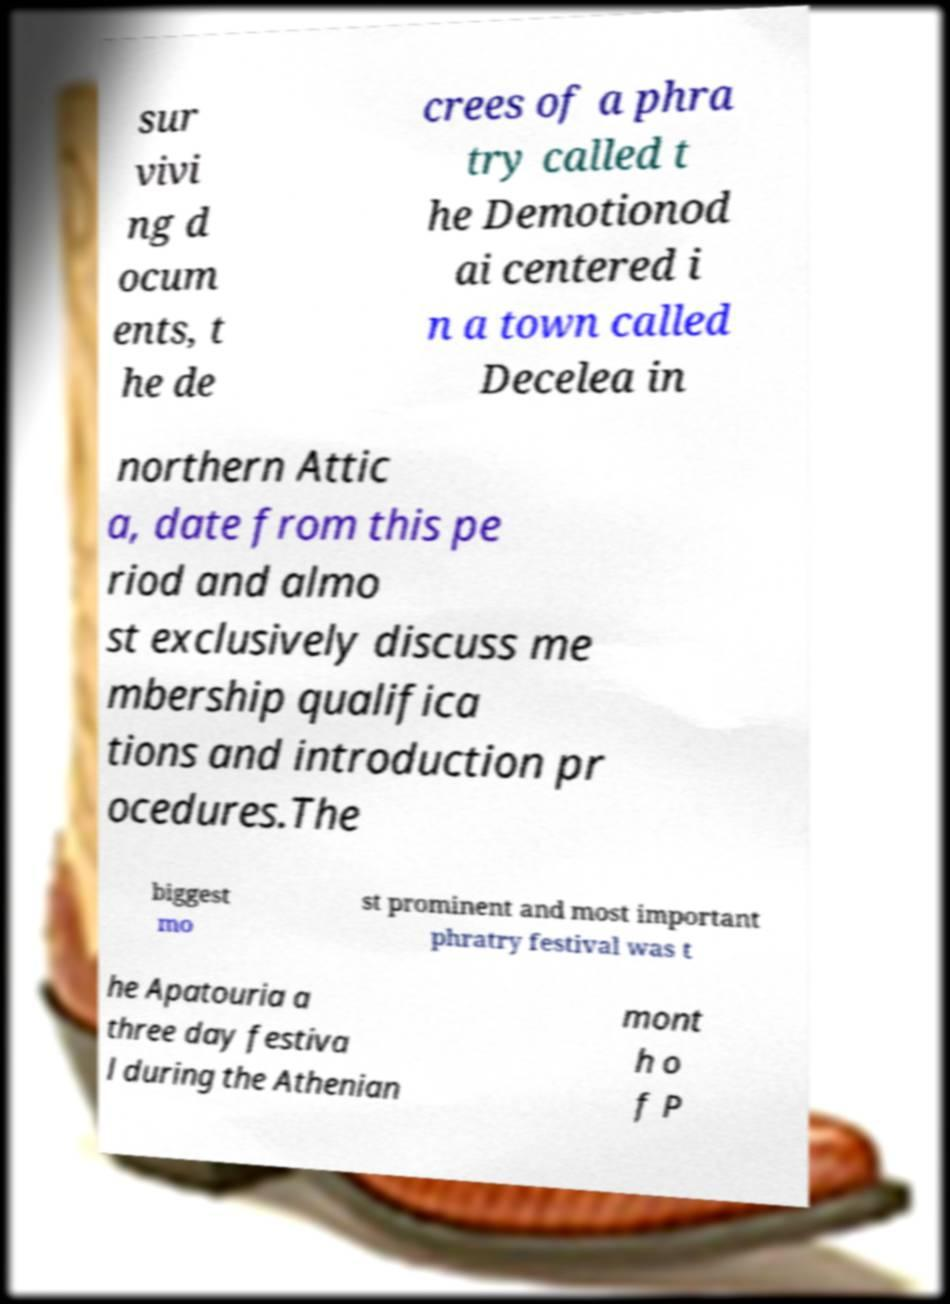There's text embedded in this image that I need extracted. Can you transcribe it verbatim? sur vivi ng d ocum ents, t he de crees of a phra try called t he Demotionod ai centered i n a town called Decelea in northern Attic a, date from this pe riod and almo st exclusively discuss me mbership qualifica tions and introduction pr ocedures.The biggest mo st prominent and most important phratry festival was t he Apatouria a three day festiva l during the Athenian mont h o f P 